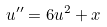<formula> <loc_0><loc_0><loc_500><loc_500>u ^ { \prime \prime } = 6 u ^ { 2 } + x</formula> 